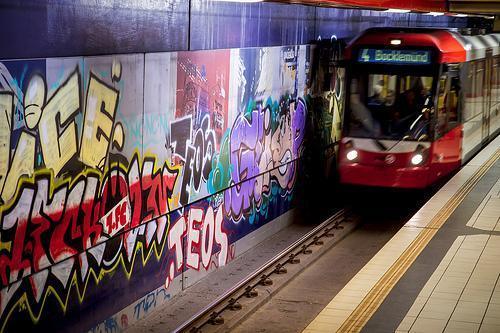How many trains are there?
Give a very brief answer. 1. 